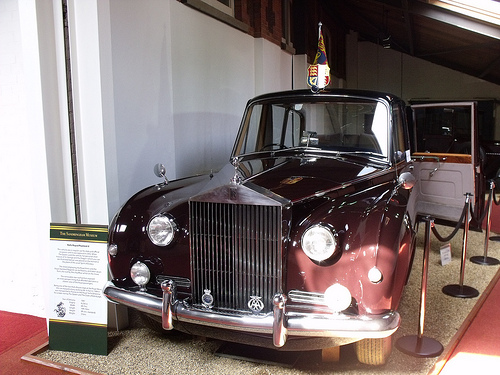<image>
Can you confirm if the flag is on the car? Yes. Looking at the image, I can see the flag is positioned on top of the car, with the car providing support. 